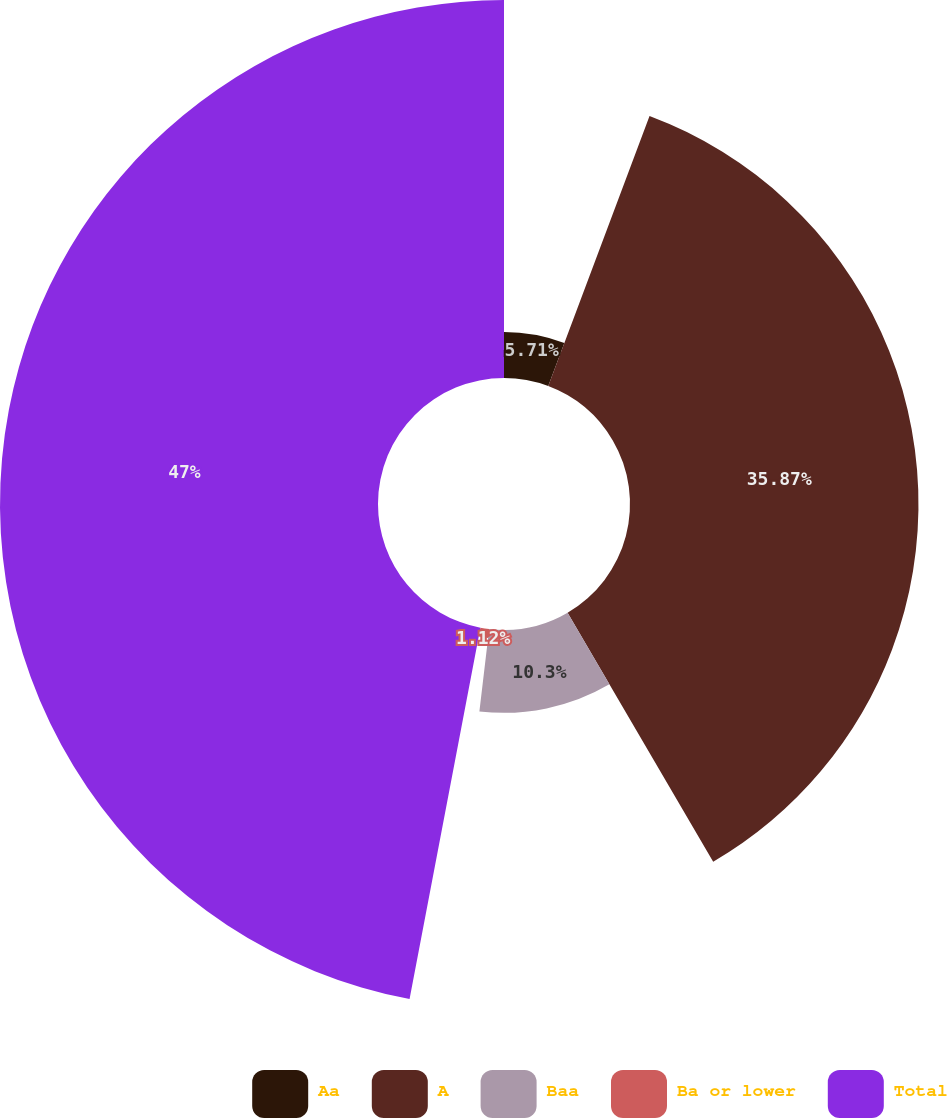Convert chart to OTSL. <chart><loc_0><loc_0><loc_500><loc_500><pie_chart><fcel>Aa<fcel>A<fcel>Baa<fcel>Ba or lower<fcel>Total<nl><fcel>5.71%<fcel>35.87%<fcel>10.3%<fcel>1.12%<fcel>47.0%<nl></chart> 